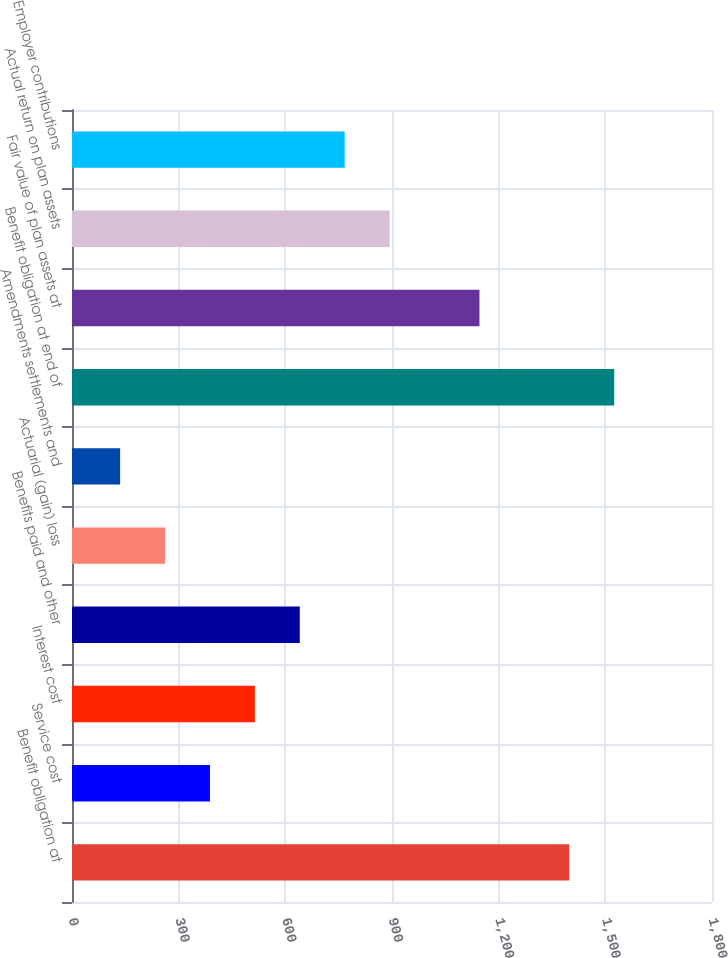<chart> <loc_0><loc_0><loc_500><loc_500><bar_chart><fcel>Benefit obligation at<fcel>Service cost<fcel>Interest cost<fcel>Benefits paid and other<fcel>Actuarial (gain) loss<fcel>Amendments settlements and<fcel>Benefit obligation at end of<fcel>Fair value of plan assets at<fcel>Actual return on plan assets<fcel>Employer contributions<nl><fcel>1398.63<fcel>387.99<fcel>514.32<fcel>640.65<fcel>261.66<fcel>135.33<fcel>1524.96<fcel>1145.97<fcel>893.31<fcel>766.98<nl></chart> 